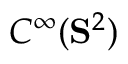Convert formula to latex. <formula><loc_0><loc_0><loc_500><loc_500>C ^ { \infty } ( S ^ { 2 } )</formula> 